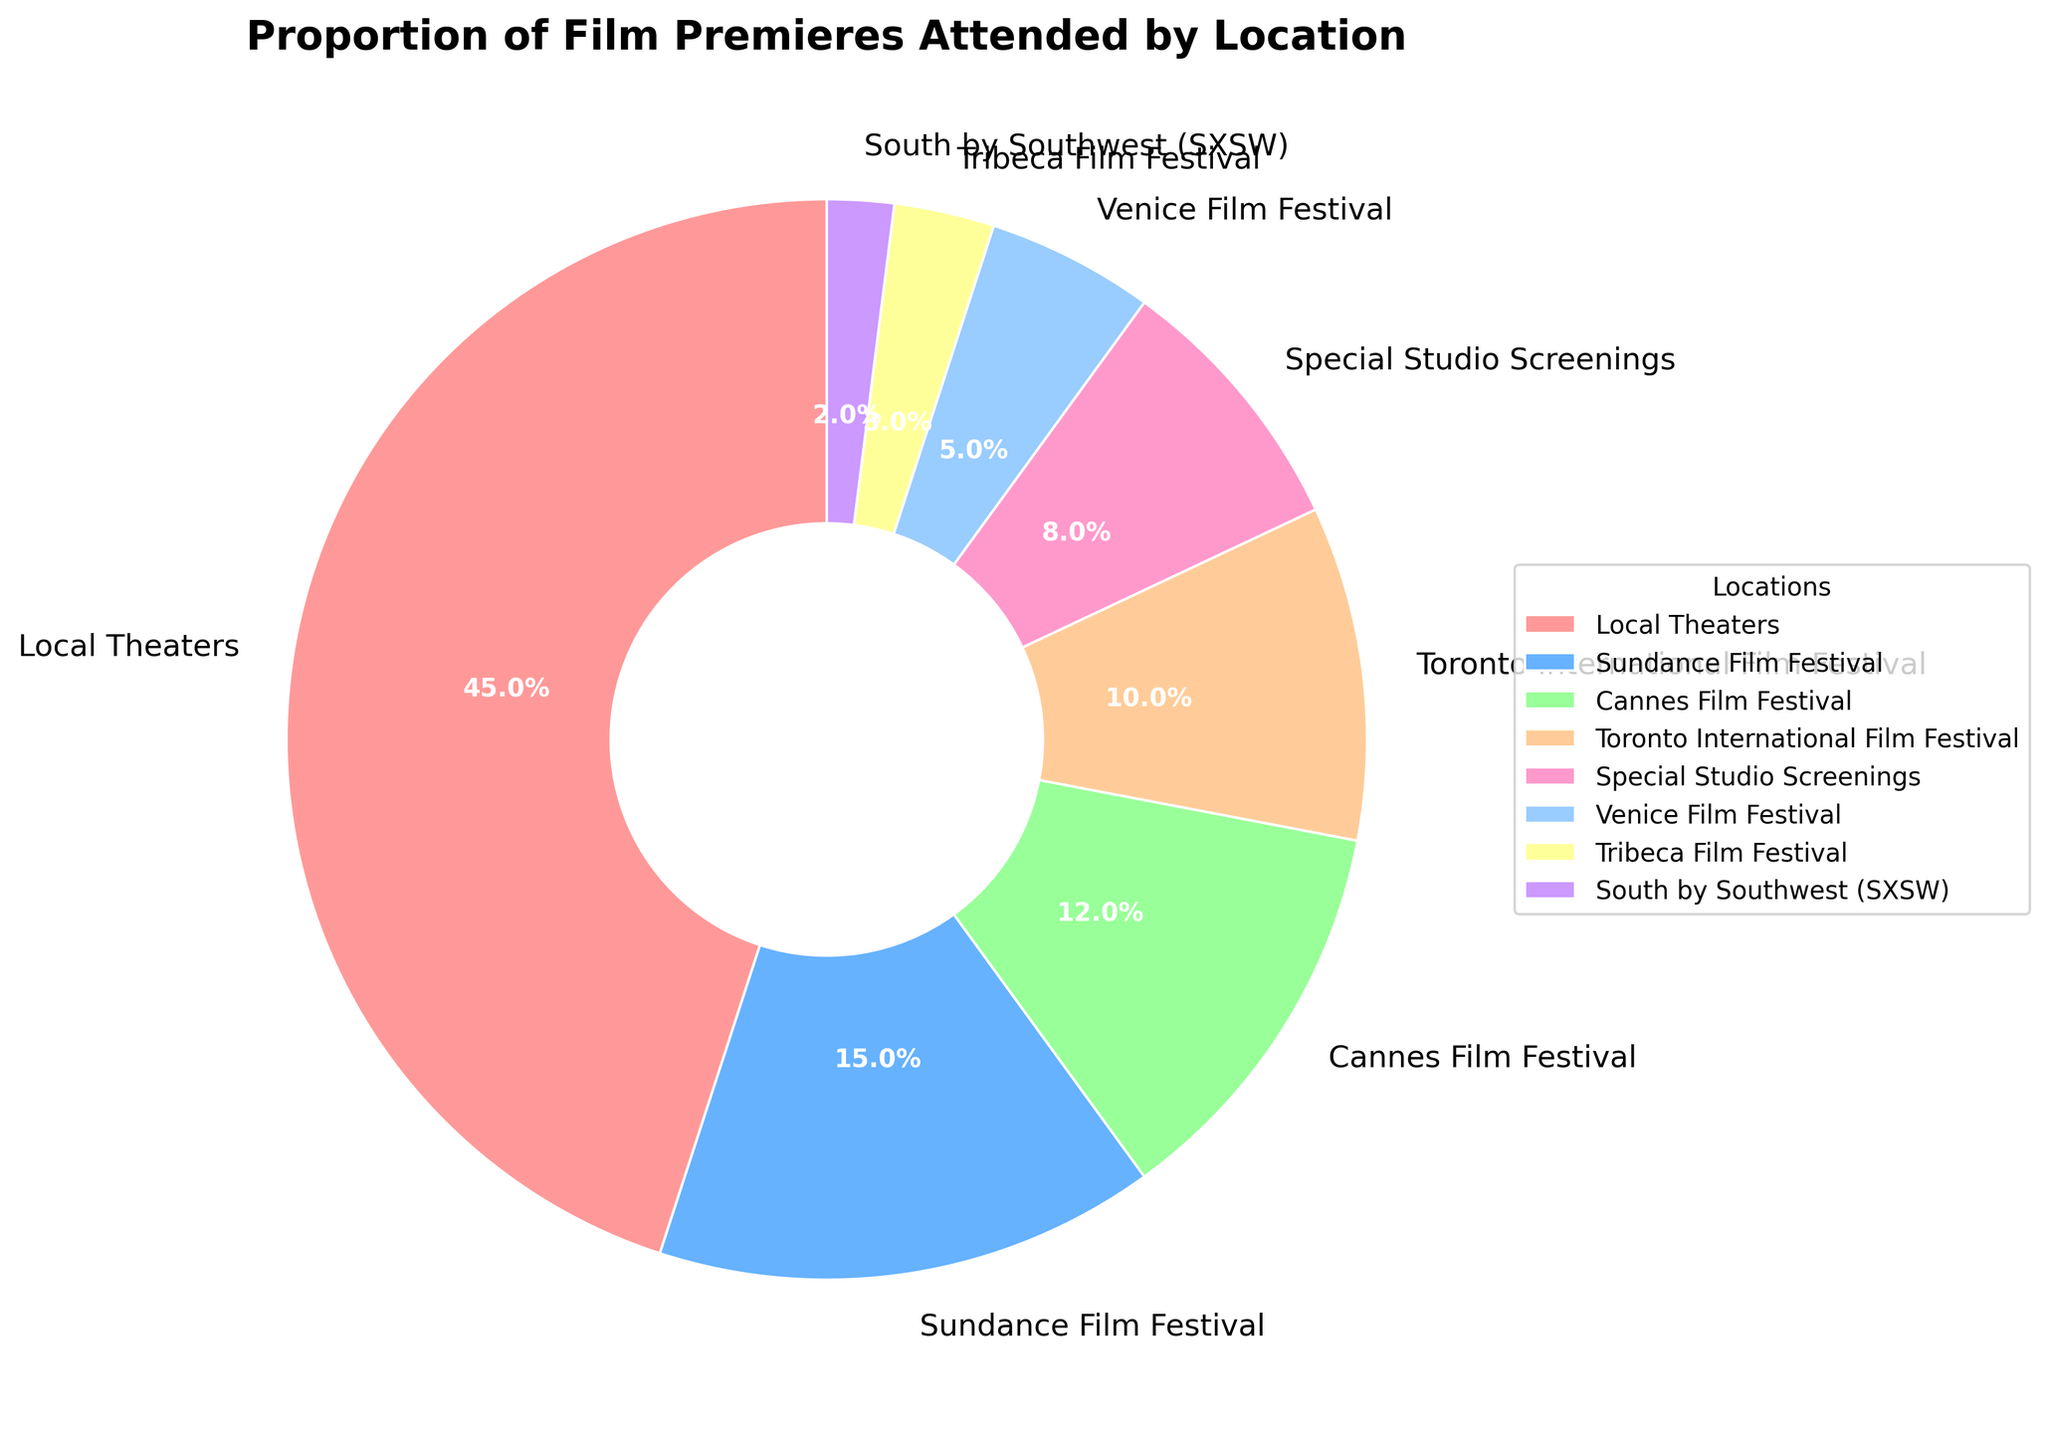What location has the highest proportion of film premieres attended? By examining the pie chart, we can observe that the segment labeled "Local Theaters" is the largest. This means that Local Theaters have the highest proportion.
Answer: Local Theaters Which location has a higher proportion of attended premieres, Toronto International Film Festival or Venice Film Festival? By comparing the sizes of the segments labeled "Toronto International Film Festival" and "Venice Film Festival", we can see that the Toronto International Film Festival comprises a larger portion of the pie chart than the Venice Film Festival.
Answer: Toronto International Film Festival What is the combined percentage of film premieres attended at both the Sundance Film Festival and the Cannes Film Festival? The percentages for the Sundance Film Festival and the Cannes Film Festival are 15% and 12%, respectively. Adding these together, 15% + 12% = 27%.
Answer: 27% Are there more premieres attended at Special Studio Screenings or at South by Southwest (SXSW)? By looking at the pie chart, the segment labeled "Special Studio Screenings" (8%) is larger than the one labeled "South by Southwest (SXSW)" (2%).
Answer: Special Studio Screenings Which festival has the smallest proportion of attended premieres? The smallest segment in the pie chart is labeled "South by Southwest (SXSW)", indicating it has the smallest proportion.
Answer: South by Southwest (SXSW) How much greater is the percentage of premieres attended at Local Theaters compared to the Tribeca Film Festival? Local Theaters have 45% and the Tribeca Film Festival has 3%. The difference is calculated as 45% - 3% = 42%.
Answer: 42% What is the total percentage of film premieres attended at all film festivals combined? Summing the percentages for Sundance Film Festival (15%), Cannes Film Festival (12%), Toronto International Film Festival (10%), Venice Film Festival (5%), Tribeca Film Festival (3%), and South by Southwest (SXSW) (2%) gives us 15% + 12% + 10% + 5% + 3% + 2% = 47%.
Answer: 47% Which two locations combined have a lower percentage of premieres attended than the Sundance Film Festival? Special Studio Screenings (8%) and Venice Film Festival (5%) together have a percentage of 8% + 5% = 13%, which is lower than the Sundance Film Festival's 15%.
Answer: Special Studio Screenings and Venice Film Festival How many locations have a proportion of 10% or higher? The locations with 10% or higher are Local Theaters (45%), Sundance Film Festival (15%), Cannes Film Festival (12%), and Toronto International Film Festival (10%). There are 4 such locations.
Answer: 4 